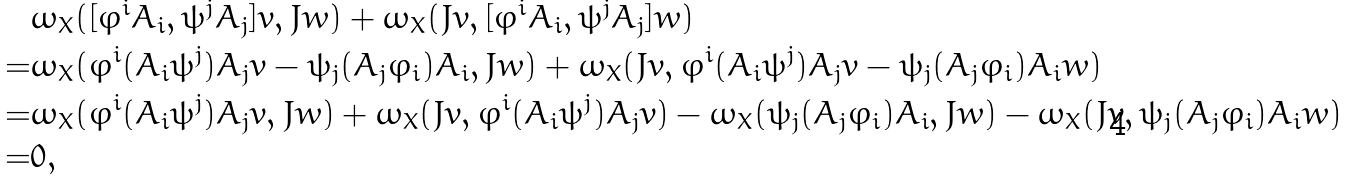Convert formula to latex. <formula><loc_0><loc_0><loc_500><loc_500>& \omega _ { X } ( [ \varphi ^ { i } A _ { i } , \psi ^ { j } A _ { j } ] v , J w ) + \omega _ { X } ( J v , [ \varphi ^ { i } A _ { i } , \psi ^ { j } A _ { j } ] w ) \\ = & \omega _ { X } ( \varphi ^ { i } ( A _ { i } \psi ^ { j } ) A _ { j } v - \psi _ { j } ( A _ { j } \varphi _ { i } ) A _ { i } , J w ) + \omega _ { X } ( J v , \varphi ^ { i } ( A _ { i } \psi ^ { j } ) A _ { j } v - \psi _ { j } ( A _ { j } \varphi _ { i } ) A _ { i } w ) \\ = & \omega _ { X } ( \varphi ^ { i } ( A _ { i } \psi ^ { j } ) A _ { j } v , J w ) + \omega _ { X } ( J v , \varphi ^ { i } ( A _ { i } \psi ^ { j } ) A _ { j } v ) - \omega _ { X } ( \psi _ { j } ( A _ { j } \varphi _ { i } ) A _ { i } , J w ) - \omega _ { X } ( J v , \psi _ { j } ( A _ { j } \varphi _ { i } ) A _ { i } w ) \\ = & 0 ,</formula> 